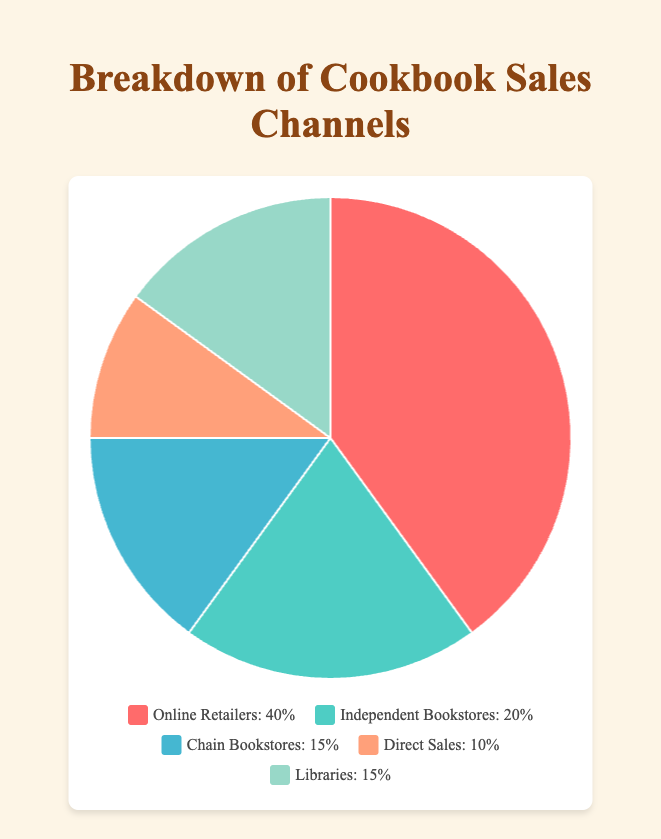Which sales channel accounts for the largest percentage of cookbook sales? The pie chart shows that the "Online Retailers" segment has the largest portion of the pie, which corresponds to 40%.
Answer: Online Retailers How do the sales percentages of Independent Bookstores and Chain Bookstores compare? From the chart, Independent Bookstores have a sales percentage of 20% and Chain Bookstores have 15%. Comparing these, Independent Bookstores have a higher percentage than Chain Bookstores.
Answer: Independent Bookstores have a higher percentage What is the combined sales percentage of Chain Bookstores and Libraries? According to the figure, Chain Bookstores account for 15% and Libraries also account for 15%. Summing these together, we get 15% + 15% = 30%.
Answer: 30% Calculate the difference in sales percentage between Online Retailers and Direct Sales. The chart shows Online Retailers at 40% and Direct Sales at 10%. The difference between them is 40% - 10% = 30%.
Answer: 30% Which sales channel has the smallest share, and what is its percentage? The chart indicates that the smallest share comes from "Direct Sales," which accounts for 10% of the sales.
Answer: Direct Sales (10%) What is the average sales percentage of all channels? The total percentage is 100%, and there are 5 channels. The average is calculated as 100% / 5 = 20%.
Answer: 20% Identify the color representing Libraries in the pie chart. The legend shows that the Libraries segment is illustrated by a mint green color.
Answer: Mint green Compare the total sales percentage of Independent Bookstores and Direct Sales with Online Retailers. Which is greater? Independent Bookstores (20%) + Direct Sales (10%) equals 30%. Online Retailers alone account for 40%. Hence, Online Retailers have a greater sales percentage.
Answer: Online Retailers What fraction of the total cookbook sales do the Independent Bookstores and Libraries together represent? According to the pie chart, Independent Bookstores have 20% and Libraries have 15%. Together, they represent 35% of the total. Converting this percentage into a fraction, we get 35/100 or simplified as 7/20.
Answer: 7/20 